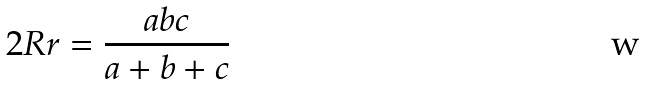Convert formula to latex. <formula><loc_0><loc_0><loc_500><loc_500>2 R r = { \frac { a b c } { a + b + c } }</formula> 